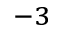Convert formula to latex. <formula><loc_0><loc_0><loc_500><loc_500>^ { - 3 }</formula> 